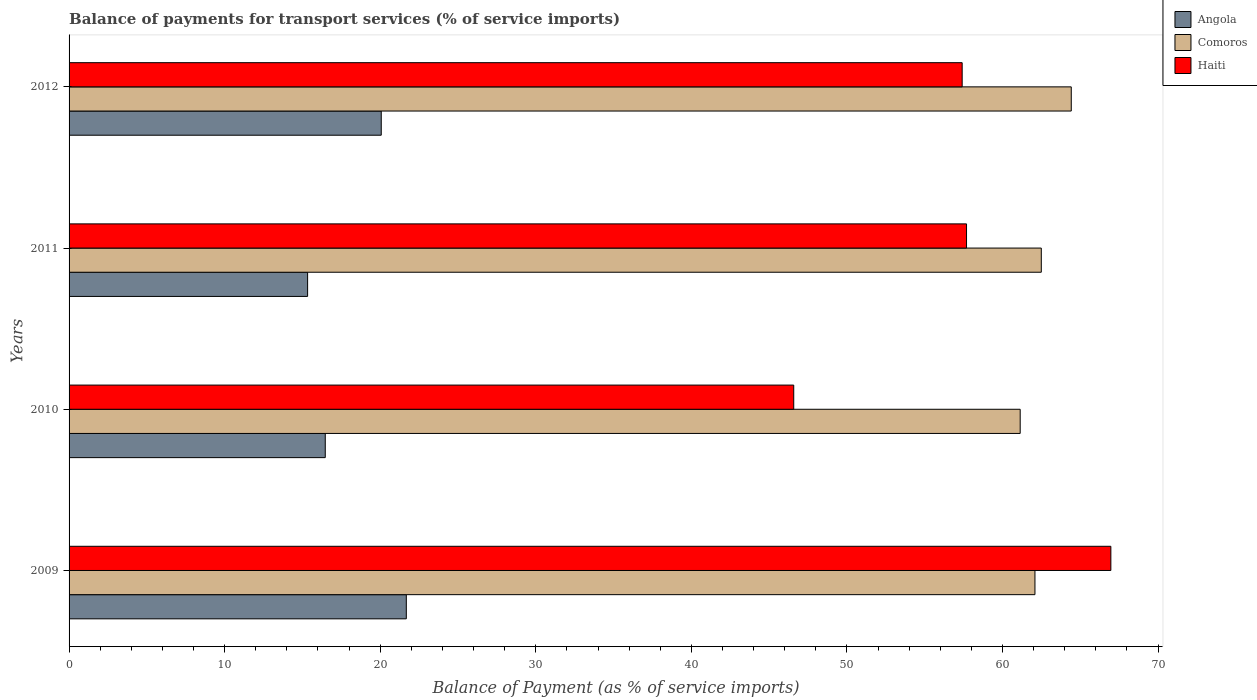Are the number of bars per tick equal to the number of legend labels?
Provide a succinct answer. Yes. How many bars are there on the 1st tick from the bottom?
Provide a short and direct response. 3. In how many cases, is the number of bars for a given year not equal to the number of legend labels?
Provide a succinct answer. 0. What is the balance of payments for transport services in Haiti in 2012?
Your answer should be very brief. 57.41. Across all years, what is the maximum balance of payments for transport services in Haiti?
Provide a succinct answer. 66.97. Across all years, what is the minimum balance of payments for transport services in Haiti?
Keep it short and to the point. 46.58. In which year was the balance of payments for transport services in Haiti maximum?
Provide a succinct answer. 2009. In which year was the balance of payments for transport services in Comoros minimum?
Your answer should be very brief. 2010. What is the total balance of payments for transport services in Haiti in the graph?
Your answer should be compact. 228.64. What is the difference between the balance of payments for transport services in Haiti in 2009 and that in 2010?
Your answer should be very brief. 20.38. What is the difference between the balance of payments for transport services in Haiti in 2011 and the balance of payments for transport services in Angola in 2012?
Keep it short and to the point. 37.62. What is the average balance of payments for transport services in Haiti per year?
Your answer should be compact. 57.16. In the year 2010, what is the difference between the balance of payments for transport services in Haiti and balance of payments for transport services in Angola?
Your response must be concise. 30.11. What is the ratio of the balance of payments for transport services in Angola in 2009 to that in 2012?
Offer a very short reply. 1.08. Is the difference between the balance of payments for transport services in Haiti in 2009 and 2011 greater than the difference between the balance of payments for transport services in Angola in 2009 and 2011?
Ensure brevity in your answer.  Yes. What is the difference between the highest and the second highest balance of payments for transport services in Haiti?
Make the answer very short. 9.28. What is the difference between the highest and the lowest balance of payments for transport services in Angola?
Your answer should be compact. 6.34. What does the 1st bar from the top in 2010 represents?
Your response must be concise. Haiti. What does the 3rd bar from the bottom in 2012 represents?
Your answer should be compact. Haiti. How many bars are there?
Keep it short and to the point. 12. Are the values on the major ticks of X-axis written in scientific E-notation?
Offer a terse response. No. Where does the legend appear in the graph?
Your response must be concise. Top right. How many legend labels are there?
Give a very brief answer. 3. What is the title of the graph?
Offer a very short reply. Balance of payments for transport services (% of service imports). What is the label or title of the X-axis?
Your answer should be compact. Balance of Payment (as % of service imports). What is the label or title of the Y-axis?
Your response must be concise. Years. What is the Balance of Payment (as % of service imports) of Angola in 2009?
Provide a succinct answer. 21.68. What is the Balance of Payment (as % of service imports) of Comoros in 2009?
Provide a succinct answer. 62.09. What is the Balance of Payment (as % of service imports) in Haiti in 2009?
Offer a very short reply. 66.97. What is the Balance of Payment (as % of service imports) in Angola in 2010?
Your answer should be very brief. 16.47. What is the Balance of Payment (as % of service imports) in Comoros in 2010?
Provide a short and direct response. 61.14. What is the Balance of Payment (as % of service imports) of Haiti in 2010?
Ensure brevity in your answer.  46.58. What is the Balance of Payment (as % of service imports) in Angola in 2011?
Give a very brief answer. 15.33. What is the Balance of Payment (as % of service imports) in Comoros in 2011?
Ensure brevity in your answer.  62.49. What is the Balance of Payment (as % of service imports) of Haiti in 2011?
Offer a terse response. 57.69. What is the Balance of Payment (as % of service imports) of Angola in 2012?
Ensure brevity in your answer.  20.07. What is the Balance of Payment (as % of service imports) of Comoros in 2012?
Your answer should be very brief. 64.42. What is the Balance of Payment (as % of service imports) in Haiti in 2012?
Provide a succinct answer. 57.41. Across all years, what is the maximum Balance of Payment (as % of service imports) in Angola?
Your answer should be compact. 21.68. Across all years, what is the maximum Balance of Payment (as % of service imports) in Comoros?
Keep it short and to the point. 64.42. Across all years, what is the maximum Balance of Payment (as % of service imports) of Haiti?
Offer a very short reply. 66.97. Across all years, what is the minimum Balance of Payment (as % of service imports) in Angola?
Offer a very short reply. 15.33. Across all years, what is the minimum Balance of Payment (as % of service imports) in Comoros?
Provide a short and direct response. 61.14. Across all years, what is the minimum Balance of Payment (as % of service imports) of Haiti?
Your answer should be compact. 46.58. What is the total Balance of Payment (as % of service imports) of Angola in the graph?
Your response must be concise. 73.55. What is the total Balance of Payment (as % of service imports) of Comoros in the graph?
Offer a very short reply. 250.14. What is the total Balance of Payment (as % of service imports) in Haiti in the graph?
Make the answer very short. 228.64. What is the difference between the Balance of Payment (as % of service imports) of Angola in 2009 and that in 2010?
Offer a very short reply. 5.21. What is the difference between the Balance of Payment (as % of service imports) of Comoros in 2009 and that in 2010?
Ensure brevity in your answer.  0.95. What is the difference between the Balance of Payment (as % of service imports) of Haiti in 2009 and that in 2010?
Offer a very short reply. 20.38. What is the difference between the Balance of Payment (as % of service imports) in Angola in 2009 and that in 2011?
Your response must be concise. 6.34. What is the difference between the Balance of Payment (as % of service imports) of Comoros in 2009 and that in 2011?
Offer a very short reply. -0.41. What is the difference between the Balance of Payment (as % of service imports) of Haiti in 2009 and that in 2011?
Your answer should be very brief. 9.28. What is the difference between the Balance of Payment (as % of service imports) of Angola in 2009 and that in 2012?
Ensure brevity in your answer.  1.61. What is the difference between the Balance of Payment (as % of service imports) of Comoros in 2009 and that in 2012?
Your response must be concise. -2.33. What is the difference between the Balance of Payment (as % of service imports) of Haiti in 2009 and that in 2012?
Offer a terse response. 9.56. What is the difference between the Balance of Payment (as % of service imports) in Angola in 2010 and that in 2011?
Give a very brief answer. 1.14. What is the difference between the Balance of Payment (as % of service imports) of Comoros in 2010 and that in 2011?
Give a very brief answer. -1.36. What is the difference between the Balance of Payment (as % of service imports) in Haiti in 2010 and that in 2011?
Offer a terse response. -11.11. What is the difference between the Balance of Payment (as % of service imports) in Angola in 2010 and that in 2012?
Provide a succinct answer. -3.6. What is the difference between the Balance of Payment (as % of service imports) of Comoros in 2010 and that in 2012?
Ensure brevity in your answer.  -3.28. What is the difference between the Balance of Payment (as % of service imports) in Haiti in 2010 and that in 2012?
Give a very brief answer. -10.83. What is the difference between the Balance of Payment (as % of service imports) of Angola in 2011 and that in 2012?
Give a very brief answer. -4.73. What is the difference between the Balance of Payment (as % of service imports) in Comoros in 2011 and that in 2012?
Keep it short and to the point. -1.93. What is the difference between the Balance of Payment (as % of service imports) of Haiti in 2011 and that in 2012?
Offer a very short reply. 0.28. What is the difference between the Balance of Payment (as % of service imports) of Angola in 2009 and the Balance of Payment (as % of service imports) of Comoros in 2010?
Your answer should be very brief. -39.46. What is the difference between the Balance of Payment (as % of service imports) in Angola in 2009 and the Balance of Payment (as % of service imports) in Haiti in 2010?
Offer a terse response. -24.9. What is the difference between the Balance of Payment (as % of service imports) in Comoros in 2009 and the Balance of Payment (as % of service imports) in Haiti in 2010?
Ensure brevity in your answer.  15.51. What is the difference between the Balance of Payment (as % of service imports) in Angola in 2009 and the Balance of Payment (as % of service imports) in Comoros in 2011?
Make the answer very short. -40.82. What is the difference between the Balance of Payment (as % of service imports) of Angola in 2009 and the Balance of Payment (as % of service imports) of Haiti in 2011?
Make the answer very short. -36.01. What is the difference between the Balance of Payment (as % of service imports) in Comoros in 2009 and the Balance of Payment (as % of service imports) in Haiti in 2011?
Make the answer very short. 4.4. What is the difference between the Balance of Payment (as % of service imports) of Angola in 2009 and the Balance of Payment (as % of service imports) of Comoros in 2012?
Your response must be concise. -42.74. What is the difference between the Balance of Payment (as % of service imports) in Angola in 2009 and the Balance of Payment (as % of service imports) in Haiti in 2012?
Provide a short and direct response. -35.73. What is the difference between the Balance of Payment (as % of service imports) in Comoros in 2009 and the Balance of Payment (as % of service imports) in Haiti in 2012?
Make the answer very short. 4.68. What is the difference between the Balance of Payment (as % of service imports) in Angola in 2010 and the Balance of Payment (as % of service imports) in Comoros in 2011?
Provide a succinct answer. -46.03. What is the difference between the Balance of Payment (as % of service imports) in Angola in 2010 and the Balance of Payment (as % of service imports) in Haiti in 2011?
Give a very brief answer. -41.22. What is the difference between the Balance of Payment (as % of service imports) of Comoros in 2010 and the Balance of Payment (as % of service imports) of Haiti in 2011?
Your answer should be compact. 3.45. What is the difference between the Balance of Payment (as % of service imports) in Angola in 2010 and the Balance of Payment (as % of service imports) in Comoros in 2012?
Ensure brevity in your answer.  -47.95. What is the difference between the Balance of Payment (as % of service imports) of Angola in 2010 and the Balance of Payment (as % of service imports) of Haiti in 2012?
Offer a terse response. -40.94. What is the difference between the Balance of Payment (as % of service imports) of Comoros in 2010 and the Balance of Payment (as % of service imports) of Haiti in 2012?
Make the answer very short. 3.73. What is the difference between the Balance of Payment (as % of service imports) of Angola in 2011 and the Balance of Payment (as % of service imports) of Comoros in 2012?
Provide a short and direct response. -49.09. What is the difference between the Balance of Payment (as % of service imports) in Angola in 2011 and the Balance of Payment (as % of service imports) in Haiti in 2012?
Your response must be concise. -42.07. What is the difference between the Balance of Payment (as % of service imports) in Comoros in 2011 and the Balance of Payment (as % of service imports) in Haiti in 2012?
Provide a succinct answer. 5.09. What is the average Balance of Payment (as % of service imports) of Angola per year?
Give a very brief answer. 18.39. What is the average Balance of Payment (as % of service imports) of Comoros per year?
Your answer should be compact. 62.53. What is the average Balance of Payment (as % of service imports) in Haiti per year?
Ensure brevity in your answer.  57.16. In the year 2009, what is the difference between the Balance of Payment (as % of service imports) in Angola and Balance of Payment (as % of service imports) in Comoros?
Your answer should be compact. -40.41. In the year 2009, what is the difference between the Balance of Payment (as % of service imports) of Angola and Balance of Payment (as % of service imports) of Haiti?
Your response must be concise. -45.29. In the year 2009, what is the difference between the Balance of Payment (as % of service imports) in Comoros and Balance of Payment (as % of service imports) in Haiti?
Provide a succinct answer. -4.88. In the year 2010, what is the difference between the Balance of Payment (as % of service imports) in Angola and Balance of Payment (as % of service imports) in Comoros?
Make the answer very short. -44.67. In the year 2010, what is the difference between the Balance of Payment (as % of service imports) of Angola and Balance of Payment (as % of service imports) of Haiti?
Make the answer very short. -30.11. In the year 2010, what is the difference between the Balance of Payment (as % of service imports) in Comoros and Balance of Payment (as % of service imports) in Haiti?
Your answer should be very brief. 14.56. In the year 2011, what is the difference between the Balance of Payment (as % of service imports) in Angola and Balance of Payment (as % of service imports) in Comoros?
Your answer should be compact. -47.16. In the year 2011, what is the difference between the Balance of Payment (as % of service imports) of Angola and Balance of Payment (as % of service imports) of Haiti?
Your answer should be very brief. -42.35. In the year 2011, what is the difference between the Balance of Payment (as % of service imports) in Comoros and Balance of Payment (as % of service imports) in Haiti?
Make the answer very short. 4.81. In the year 2012, what is the difference between the Balance of Payment (as % of service imports) in Angola and Balance of Payment (as % of service imports) in Comoros?
Provide a short and direct response. -44.35. In the year 2012, what is the difference between the Balance of Payment (as % of service imports) of Angola and Balance of Payment (as % of service imports) of Haiti?
Offer a terse response. -37.34. In the year 2012, what is the difference between the Balance of Payment (as % of service imports) of Comoros and Balance of Payment (as % of service imports) of Haiti?
Ensure brevity in your answer.  7.01. What is the ratio of the Balance of Payment (as % of service imports) of Angola in 2009 to that in 2010?
Keep it short and to the point. 1.32. What is the ratio of the Balance of Payment (as % of service imports) in Comoros in 2009 to that in 2010?
Offer a terse response. 1.02. What is the ratio of the Balance of Payment (as % of service imports) of Haiti in 2009 to that in 2010?
Offer a very short reply. 1.44. What is the ratio of the Balance of Payment (as % of service imports) in Angola in 2009 to that in 2011?
Your answer should be compact. 1.41. What is the ratio of the Balance of Payment (as % of service imports) in Haiti in 2009 to that in 2011?
Give a very brief answer. 1.16. What is the ratio of the Balance of Payment (as % of service imports) of Angola in 2009 to that in 2012?
Provide a short and direct response. 1.08. What is the ratio of the Balance of Payment (as % of service imports) of Comoros in 2009 to that in 2012?
Keep it short and to the point. 0.96. What is the ratio of the Balance of Payment (as % of service imports) of Haiti in 2009 to that in 2012?
Provide a short and direct response. 1.17. What is the ratio of the Balance of Payment (as % of service imports) in Angola in 2010 to that in 2011?
Your answer should be compact. 1.07. What is the ratio of the Balance of Payment (as % of service imports) in Comoros in 2010 to that in 2011?
Offer a terse response. 0.98. What is the ratio of the Balance of Payment (as % of service imports) of Haiti in 2010 to that in 2011?
Ensure brevity in your answer.  0.81. What is the ratio of the Balance of Payment (as % of service imports) of Angola in 2010 to that in 2012?
Offer a very short reply. 0.82. What is the ratio of the Balance of Payment (as % of service imports) in Comoros in 2010 to that in 2012?
Give a very brief answer. 0.95. What is the ratio of the Balance of Payment (as % of service imports) in Haiti in 2010 to that in 2012?
Provide a short and direct response. 0.81. What is the ratio of the Balance of Payment (as % of service imports) in Angola in 2011 to that in 2012?
Give a very brief answer. 0.76. What is the ratio of the Balance of Payment (as % of service imports) of Comoros in 2011 to that in 2012?
Offer a very short reply. 0.97. What is the difference between the highest and the second highest Balance of Payment (as % of service imports) in Angola?
Make the answer very short. 1.61. What is the difference between the highest and the second highest Balance of Payment (as % of service imports) of Comoros?
Offer a very short reply. 1.93. What is the difference between the highest and the second highest Balance of Payment (as % of service imports) in Haiti?
Ensure brevity in your answer.  9.28. What is the difference between the highest and the lowest Balance of Payment (as % of service imports) in Angola?
Keep it short and to the point. 6.34. What is the difference between the highest and the lowest Balance of Payment (as % of service imports) of Comoros?
Your answer should be compact. 3.28. What is the difference between the highest and the lowest Balance of Payment (as % of service imports) in Haiti?
Your answer should be very brief. 20.38. 